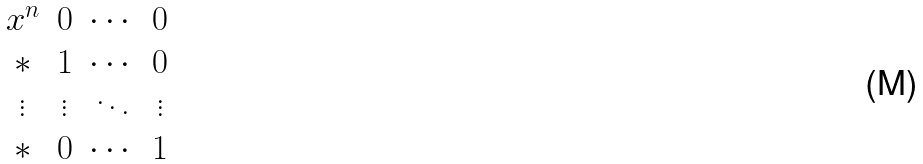<formula> <loc_0><loc_0><loc_500><loc_500>\begin{matrix} x ^ { n } & 0 & \cdots & 0 \\ * & 1 & \cdots & 0 \\ \vdots & \vdots & \ddots & \vdots \\ * & 0 & \cdots & 1 \end{matrix}</formula> 